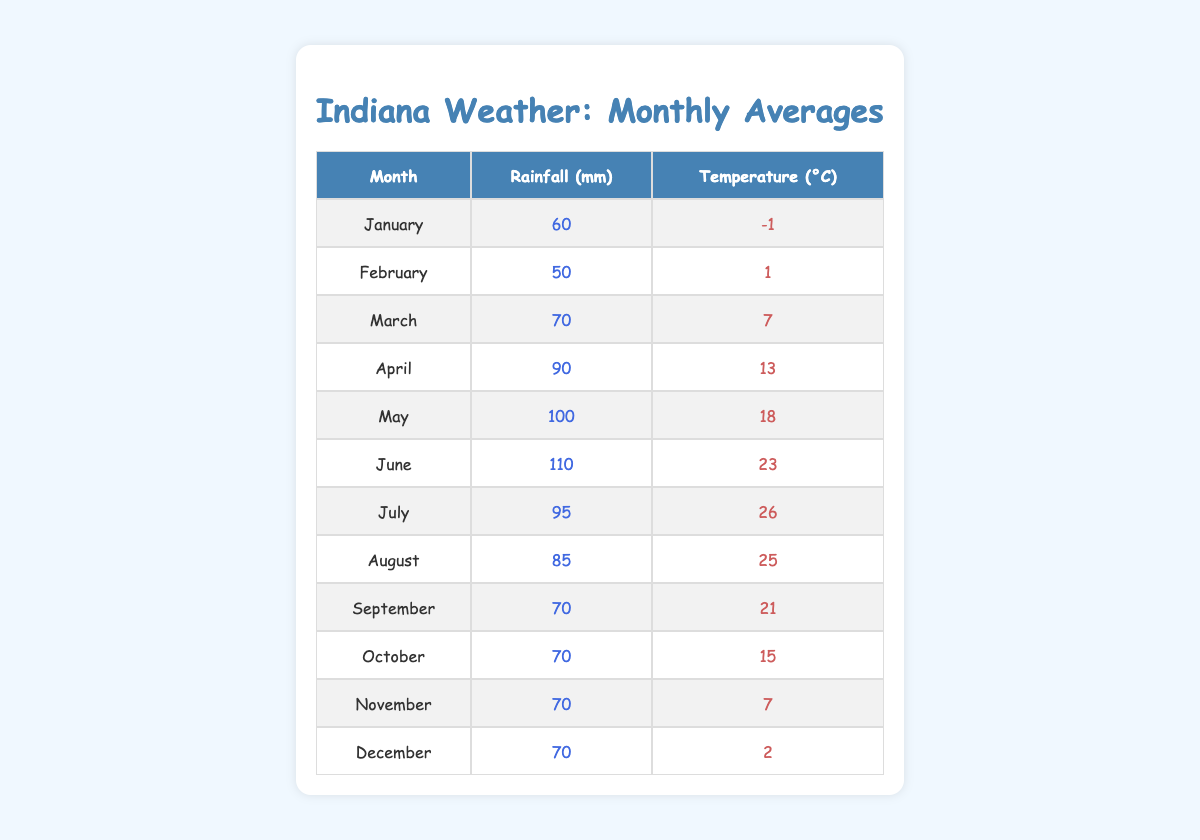What is the average temperature in July? The table shows that the temperature in July is 26°C.
Answer: 26°C How much rainfall is recorded in May? According to the table, the rainfall in May is listed as 100 mm.
Answer: 100 mm In which month does Indiana have the highest temperature? Looking at the temperatures listed, July has the highest recorded temperature at 26°C.
Answer: July What is the rainfall difference between April and June? April has 90 mm of rainfall and June has 110 mm. The difference is 110 - 90 = 20 mm.
Answer: 20 mm Is the rainfall in February higher than in January? February has 50 mm and January has 60 mm, therefore February’s rainfall is not higher than January's.
Answer: No What is the cumulative rainfall from January to March? The rainfalls are: January (60 mm), February (50 mm), and March (70 mm). Adding these gives 60 + 50 + 70 = 180 mm.
Answer: 180 mm Which month has the lowest average temperature? January has the lowest average temperature of -1°C, which is less than any other month listed.
Answer: January How does the average temperature in October compare to that in December? October has a temperature of 15°C while December has 2°C. Therefore, October is warmer than December.
Answer: October is warmer What is the total rainfall for the months of April, May, and June? The rainfall amounts are: April (90 mm), May (100 mm), June (110 mm). The total is 90 + 100 + 110 = 300 mm.
Answer: 300 mm Which month has a temperature lower than 5°C? January (-1°C), February (1°C), and November (7°C) have temperatures below 5°C. Among these, January is the lowest.
Answer: January 